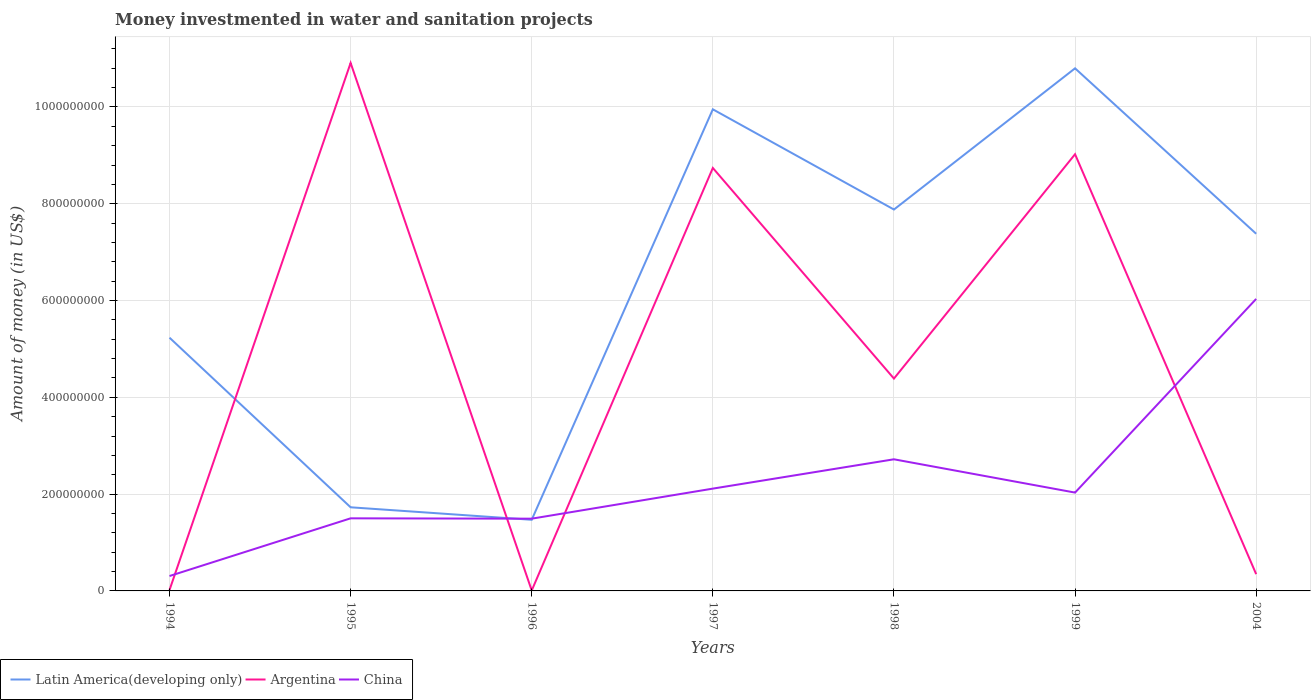Does the line corresponding to China intersect with the line corresponding to Argentina?
Your answer should be very brief. Yes. Is the number of lines equal to the number of legend labels?
Offer a very short reply. Yes. Across all years, what is the maximum money investmented in water and sanitation projects in China?
Provide a succinct answer. 3.08e+07. What is the total money investmented in water and sanitation projects in Argentina in the graph?
Your answer should be compact. -9.02e+08. What is the difference between the highest and the second highest money investmented in water and sanitation projects in Latin America(developing only)?
Your answer should be very brief. 9.33e+08. What is the difference between the highest and the lowest money investmented in water and sanitation projects in Latin America(developing only)?
Your answer should be very brief. 4. How many lines are there?
Offer a very short reply. 3. Does the graph contain any zero values?
Your response must be concise. No. Does the graph contain grids?
Ensure brevity in your answer.  Yes. Where does the legend appear in the graph?
Your answer should be compact. Bottom left. How many legend labels are there?
Your response must be concise. 3. What is the title of the graph?
Your answer should be very brief. Money investmented in water and sanitation projects. What is the label or title of the Y-axis?
Make the answer very short. Amount of money (in US$). What is the Amount of money (in US$) in Latin America(developing only) in 1994?
Make the answer very short. 5.23e+08. What is the Amount of money (in US$) in Argentina in 1994?
Keep it short and to the point. 1.90e+06. What is the Amount of money (in US$) of China in 1994?
Keep it short and to the point. 3.08e+07. What is the Amount of money (in US$) of Latin America(developing only) in 1995?
Your answer should be compact. 1.73e+08. What is the Amount of money (in US$) in Argentina in 1995?
Your answer should be compact. 1.09e+09. What is the Amount of money (in US$) in China in 1995?
Your response must be concise. 1.50e+08. What is the Amount of money (in US$) of Latin America(developing only) in 1996?
Provide a short and direct response. 1.47e+08. What is the Amount of money (in US$) of China in 1996?
Your answer should be very brief. 1.49e+08. What is the Amount of money (in US$) of Latin America(developing only) in 1997?
Make the answer very short. 9.95e+08. What is the Amount of money (in US$) of Argentina in 1997?
Keep it short and to the point. 8.74e+08. What is the Amount of money (in US$) in China in 1997?
Offer a very short reply. 2.11e+08. What is the Amount of money (in US$) in Latin America(developing only) in 1998?
Keep it short and to the point. 7.88e+08. What is the Amount of money (in US$) in Argentina in 1998?
Provide a short and direct response. 4.39e+08. What is the Amount of money (in US$) of China in 1998?
Your response must be concise. 2.72e+08. What is the Amount of money (in US$) of Latin America(developing only) in 1999?
Provide a short and direct response. 1.08e+09. What is the Amount of money (in US$) in Argentina in 1999?
Your response must be concise. 9.02e+08. What is the Amount of money (in US$) in China in 1999?
Your answer should be very brief. 2.03e+08. What is the Amount of money (in US$) of Latin America(developing only) in 2004?
Offer a terse response. 7.38e+08. What is the Amount of money (in US$) of Argentina in 2004?
Make the answer very short. 3.46e+07. What is the Amount of money (in US$) of China in 2004?
Your answer should be very brief. 6.03e+08. Across all years, what is the maximum Amount of money (in US$) of Latin America(developing only)?
Your response must be concise. 1.08e+09. Across all years, what is the maximum Amount of money (in US$) of Argentina?
Ensure brevity in your answer.  1.09e+09. Across all years, what is the maximum Amount of money (in US$) in China?
Keep it short and to the point. 6.03e+08. Across all years, what is the minimum Amount of money (in US$) of Latin America(developing only)?
Keep it short and to the point. 1.47e+08. Across all years, what is the minimum Amount of money (in US$) in China?
Ensure brevity in your answer.  3.08e+07. What is the total Amount of money (in US$) of Latin America(developing only) in the graph?
Give a very brief answer. 4.44e+09. What is the total Amount of money (in US$) of Argentina in the graph?
Provide a short and direct response. 3.34e+09. What is the total Amount of money (in US$) in China in the graph?
Your answer should be very brief. 1.62e+09. What is the difference between the Amount of money (in US$) in Latin America(developing only) in 1994 and that in 1995?
Your answer should be very brief. 3.50e+08. What is the difference between the Amount of money (in US$) in Argentina in 1994 and that in 1995?
Your answer should be very brief. -1.09e+09. What is the difference between the Amount of money (in US$) in China in 1994 and that in 1995?
Ensure brevity in your answer.  -1.19e+08. What is the difference between the Amount of money (in US$) in Latin America(developing only) in 1994 and that in 1996?
Offer a very short reply. 3.76e+08. What is the difference between the Amount of money (in US$) of Argentina in 1994 and that in 1996?
Provide a succinct answer. 1.00e+06. What is the difference between the Amount of money (in US$) of China in 1994 and that in 1996?
Make the answer very short. -1.18e+08. What is the difference between the Amount of money (in US$) in Latin America(developing only) in 1994 and that in 1997?
Make the answer very short. -4.72e+08. What is the difference between the Amount of money (in US$) in Argentina in 1994 and that in 1997?
Offer a terse response. -8.72e+08. What is the difference between the Amount of money (in US$) of China in 1994 and that in 1997?
Make the answer very short. -1.81e+08. What is the difference between the Amount of money (in US$) in Latin America(developing only) in 1994 and that in 1998?
Offer a terse response. -2.65e+08. What is the difference between the Amount of money (in US$) in Argentina in 1994 and that in 1998?
Offer a terse response. -4.37e+08. What is the difference between the Amount of money (in US$) in China in 1994 and that in 1998?
Ensure brevity in your answer.  -2.41e+08. What is the difference between the Amount of money (in US$) in Latin America(developing only) in 1994 and that in 1999?
Your answer should be compact. -5.57e+08. What is the difference between the Amount of money (in US$) in Argentina in 1994 and that in 1999?
Provide a short and direct response. -9.00e+08. What is the difference between the Amount of money (in US$) of China in 1994 and that in 1999?
Provide a short and direct response. -1.72e+08. What is the difference between the Amount of money (in US$) of Latin America(developing only) in 1994 and that in 2004?
Offer a very short reply. -2.15e+08. What is the difference between the Amount of money (in US$) in Argentina in 1994 and that in 2004?
Ensure brevity in your answer.  -3.28e+07. What is the difference between the Amount of money (in US$) in China in 1994 and that in 2004?
Your answer should be compact. -5.73e+08. What is the difference between the Amount of money (in US$) of Latin America(developing only) in 1995 and that in 1996?
Your answer should be compact. 2.58e+07. What is the difference between the Amount of money (in US$) in Argentina in 1995 and that in 1996?
Give a very brief answer. 1.09e+09. What is the difference between the Amount of money (in US$) of Latin America(developing only) in 1995 and that in 1997?
Give a very brief answer. -8.22e+08. What is the difference between the Amount of money (in US$) in Argentina in 1995 and that in 1997?
Your response must be concise. 2.17e+08. What is the difference between the Amount of money (in US$) in China in 1995 and that in 1997?
Give a very brief answer. -6.14e+07. What is the difference between the Amount of money (in US$) in Latin America(developing only) in 1995 and that in 1998?
Provide a succinct answer. -6.15e+08. What is the difference between the Amount of money (in US$) in Argentina in 1995 and that in 1998?
Offer a terse response. 6.52e+08. What is the difference between the Amount of money (in US$) of China in 1995 and that in 1998?
Keep it short and to the point. -1.22e+08. What is the difference between the Amount of money (in US$) in Latin America(developing only) in 1995 and that in 1999?
Provide a short and direct response. -9.07e+08. What is the difference between the Amount of money (in US$) of Argentina in 1995 and that in 1999?
Keep it short and to the point. 1.89e+08. What is the difference between the Amount of money (in US$) of China in 1995 and that in 1999?
Ensure brevity in your answer.  -5.32e+07. What is the difference between the Amount of money (in US$) of Latin America(developing only) in 1995 and that in 2004?
Make the answer very short. -5.65e+08. What is the difference between the Amount of money (in US$) in Argentina in 1995 and that in 2004?
Give a very brief answer. 1.06e+09. What is the difference between the Amount of money (in US$) of China in 1995 and that in 2004?
Your response must be concise. -4.53e+08. What is the difference between the Amount of money (in US$) in Latin America(developing only) in 1996 and that in 1997?
Your response must be concise. -8.48e+08. What is the difference between the Amount of money (in US$) in Argentina in 1996 and that in 1997?
Your answer should be compact. -8.73e+08. What is the difference between the Amount of money (in US$) in China in 1996 and that in 1997?
Provide a succinct answer. -6.21e+07. What is the difference between the Amount of money (in US$) of Latin America(developing only) in 1996 and that in 1998?
Give a very brief answer. -6.41e+08. What is the difference between the Amount of money (in US$) of Argentina in 1996 and that in 1998?
Offer a very short reply. -4.38e+08. What is the difference between the Amount of money (in US$) in China in 1996 and that in 1998?
Your answer should be compact. -1.23e+08. What is the difference between the Amount of money (in US$) in Latin America(developing only) in 1996 and that in 1999?
Offer a very short reply. -9.33e+08. What is the difference between the Amount of money (in US$) in Argentina in 1996 and that in 1999?
Provide a short and direct response. -9.02e+08. What is the difference between the Amount of money (in US$) of China in 1996 and that in 1999?
Provide a succinct answer. -5.39e+07. What is the difference between the Amount of money (in US$) in Latin America(developing only) in 1996 and that in 2004?
Your answer should be very brief. -5.91e+08. What is the difference between the Amount of money (in US$) in Argentina in 1996 and that in 2004?
Offer a terse response. -3.38e+07. What is the difference between the Amount of money (in US$) in China in 1996 and that in 2004?
Provide a short and direct response. -4.54e+08. What is the difference between the Amount of money (in US$) in Latin America(developing only) in 1997 and that in 1998?
Keep it short and to the point. 2.07e+08. What is the difference between the Amount of money (in US$) of Argentina in 1997 and that in 1998?
Your answer should be very brief. 4.35e+08. What is the difference between the Amount of money (in US$) of China in 1997 and that in 1998?
Offer a very short reply. -6.06e+07. What is the difference between the Amount of money (in US$) in Latin America(developing only) in 1997 and that in 1999?
Your response must be concise. -8.47e+07. What is the difference between the Amount of money (in US$) of Argentina in 1997 and that in 1999?
Ensure brevity in your answer.  -2.84e+07. What is the difference between the Amount of money (in US$) in China in 1997 and that in 1999?
Offer a terse response. 8.20e+06. What is the difference between the Amount of money (in US$) in Latin America(developing only) in 1997 and that in 2004?
Keep it short and to the point. 2.57e+08. What is the difference between the Amount of money (in US$) in Argentina in 1997 and that in 2004?
Your answer should be very brief. 8.39e+08. What is the difference between the Amount of money (in US$) of China in 1997 and that in 2004?
Offer a very short reply. -3.92e+08. What is the difference between the Amount of money (in US$) in Latin America(developing only) in 1998 and that in 1999?
Your response must be concise. -2.92e+08. What is the difference between the Amount of money (in US$) of Argentina in 1998 and that in 1999?
Offer a very short reply. -4.64e+08. What is the difference between the Amount of money (in US$) in China in 1998 and that in 1999?
Offer a terse response. 6.88e+07. What is the difference between the Amount of money (in US$) of Latin America(developing only) in 1998 and that in 2004?
Provide a succinct answer. 5.01e+07. What is the difference between the Amount of money (in US$) in Argentina in 1998 and that in 2004?
Your answer should be very brief. 4.04e+08. What is the difference between the Amount of money (in US$) in China in 1998 and that in 2004?
Provide a short and direct response. -3.31e+08. What is the difference between the Amount of money (in US$) in Latin America(developing only) in 1999 and that in 2004?
Provide a short and direct response. 3.42e+08. What is the difference between the Amount of money (in US$) in Argentina in 1999 and that in 2004?
Offer a very short reply. 8.68e+08. What is the difference between the Amount of money (in US$) of China in 1999 and that in 2004?
Make the answer very short. -4.00e+08. What is the difference between the Amount of money (in US$) of Latin America(developing only) in 1994 and the Amount of money (in US$) of Argentina in 1995?
Offer a very short reply. -5.68e+08. What is the difference between the Amount of money (in US$) in Latin America(developing only) in 1994 and the Amount of money (in US$) in China in 1995?
Offer a very short reply. 3.73e+08. What is the difference between the Amount of money (in US$) of Argentina in 1994 and the Amount of money (in US$) of China in 1995?
Offer a terse response. -1.48e+08. What is the difference between the Amount of money (in US$) of Latin America(developing only) in 1994 and the Amount of money (in US$) of Argentina in 1996?
Give a very brief answer. 5.22e+08. What is the difference between the Amount of money (in US$) of Latin America(developing only) in 1994 and the Amount of money (in US$) of China in 1996?
Provide a short and direct response. 3.74e+08. What is the difference between the Amount of money (in US$) of Argentina in 1994 and the Amount of money (in US$) of China in 1996?
Offer a terse response. -1.47e+08. What is the difference between the Amount of money (in US$) in Latin America(developing only) in 1994 and the Amount of money (in US$) in Argentina in 1997?
Provide a short and direct response. -3.51e+08. What is the difference between the Amount of money (in US$) of Latin America(developing only) in 1994 and the Amount of money (in US$) of China in 1997?
Offer a very short reply. 3.12e+08. What is the difference between the Amount of money (in US$) of Argentina in 1994 and the Amount of money (in US$) of China in 1997?
Make the answer very short. -2.10e+08. What is the difference between the Amount of money (in US$) in Latin America(developing only) in 1994 and the Amount of money (in US$) in Argentina in 1998?
Your answer should be very brief. 8.45e+07. What is the difference between the Amount of money (in US$) in Latin America(developing only) in 1994 and the Amount of money (in US$) in China in 1998?
Your answer should be compact. 2.51e+08. What is the difference between the Amount of money (in US$) of Argentina in 1994 and the Amount of money (in US$) of China in 1998?
Ensure brevity in your answer.  -2.70e+08. What is the difference between the Amount of money (in US$) of Latin America(developing only) in 1994 and the Amount of money (in US$) of Argentina in 1999?
Provide a succinct answer. -3.79e+08. What is the difference between the Amount of money (in US$) in Latin America(developing only) in 1994 and the Amount of money (in US$) in China in 1999?
Your answer should be compact. 3.20e+08. What is the difference between the Amount of money (in US$) of Argentina in 1994 and the Amount of money (in US$) of China in 1999?
Your answer should be compact. -2.01e+08. What is the difference between the Amount of money (in US$) of Latin America(developing only) in 1994 and the Amount of money (in US$) of Argentina in 2004?
Provide a short and direct response. 4.89e+08. What is the difference between the Amount of money (in US$) of Latin America(developing only) in 1994 and the Amount of money (in US$) of China in 2004?
Give a very brief answer. -8.01e+07. What is the difference between the Amount of money (in US$) of Argentina in 1994 and the Amount of money (in US$) of China in 2004?
Offer a terse response. -6.01e+08. What is the difference between the Amount of money (in US$) in Latin America(developing only) in 1995 and the Amount of money (in US$) in Argentina in 1996?
Provide a short and direct response. 1.72e+08. What is the difference between the Amount of money (in US$) of Latin America(developing only) in 1995 and the Amount of money (in US$) of China in 1996?
Offer a terse response. 2.35e+07. What is the difference between the Amount of money (in US$) of Argentina in 1995 and the Amount of money (in US$) of China in 1996?
Offer a very short reply. 9.42e+08. What is the difference between the Amount of money (in US$) of Latin America(developing only) in 1995 and the Amount of money (in US$) of Argentina in 1997?
Your answer should be compact. -7.01e+08. What is the difference between the Amount of money (in US$) of Latin America(developing only) in 1995 and the Amount of money (in US$) of China in 1997?
Ensure brevity in your answer.  -3.86e+07. What is the difference between the Amount of money (in US$) in Argentina in 1995 and the Amount of money (in US$) in China in 1997?
Offer a terse response. 8.80e+08. What is the difference between the Amount of money (in US$) in Latin America(developing only) in 1995 and the Amount of money (in US$) in Argentina in 1998?
Provide a short and direct response. -2.66e+08. What is the difference between the Amount of money (in US$) of Latin America(developing only) in 1995 and the Amount of money (in US$) of China in 1998?
Offer a very short reply. -9.92e+07. What is the difference between the Amount of money (in US$) of Argentina in 1995 and the Amount of money (in US$) of China in 1998?
Keep it short and to the point. 8.19e+08. What is the difference between the Amount of money (in US$) in Latin America(developing only) in 1995 and the Amount of money (in US$) in Argentina in 1999?
Offer a terse response. -7.30e+08. What is the difference between the Amount of money (in US$) in Latin America(developing only) in 1995 and the Amount of money (in US$) in China in 1999?
Ensure brevity in your answer.  -3.04e+07. What is the difference between the Amount of money (in US$) of Argentina in 1995 and the Amount of money (in US$) of China in 1999?
Make the answer very short. 8.88e+08. What is the difference between the Amount of money (in US$) of Latin America(developing only) in 1995 and the Amount of money (in US$) of Argentina in 2004?
Make the answer very short. 1.38e+08. What is the difference between the Amount of money (in US$) of Latin America(developing only) in 1995 and the Amount of money (in US$) of China in 2004?
Ensure brevity in your answer.  -4.31e+08. What is the difference between the Amount of money (in US$) of Argentina in 1995 and the Amount of money (in US$) of China in 2004?
Provide a short and direct response. 4.88e+08. What is the difference between the Amount of money (in US$) of Latin America(developing only) in 1996 and the Amount of money (in US$) of Argentina in 1997?
Give a very brief answer. -7.27e+08. What is the difference between the Amount of money (in US$) of Latin America(developing only) in 1996 and the Amount of money (in US$) of China in 1997?
Give a very brief answer. -6.44e+07. What is the difference between the Amount of money (in US$) of Argentina in 1996 and the Amount of money (in US$) of China in 1997?
Give a very brief answer. -2.10e+08. What is the difference between the Amount of money (in US$) of Latin America(developing only) in 1996 and the Amount of money (in US$) of Argentina in 1998?
Your response must be concise. -2.92e+08. What is the difference between the Amount of money (in US$) of Latin America(developing only) in 1996 and the Amount of money (in US$) of China in 1998?
Make the answer very short. -1.25e+08. What is the difference between the Amount of money (in US$) in Argentina in 1996 and the Amount of money (in US$) in China in 1998?
Provide a succinct answer. -2.71e+08. What is the difference between the Amount of money (in US$) in Latin America(developing only) in 1996 and the Amount of money (in US$) in Argentina in 1999?
Offer a very short reply. -7.55e+08. What is the difference between the Amount of money (in US$) of Latin America(developing only) in 1996 and the Amount of money (in US$) of China in 1999?
Your response must be concise. -5.62e+07. What is the difference between the Amount of money (in US$) of Argentina in 1996 and the Amount of money (in US$) of China in 1999?
Keep it short and to the point. -2.02e+08. What is the difference between the Amount of money (in US$) in Latin America(developing only) in 1996 and the Amount of money (in US$) in Argentina in 2004?
Ensure brevity in your answer.  1.12e+08. What is the difference between the Amount of money (in US$) of Latin America(developing only) in 1996 and the Amount of money (in US$) of China in 2004?
Give a very brief answer. -4.56e+08. What is the difference between the Amount of money (in US$) of Argentina in 1996 and the Amount of money (in US$) of China in 2004?
Your answer should be compact. -6.02e+08. What is the difference between the Amount of money (in US$) of Latin America(developing only) in 1997 and the Amount of money (in US$) of Argentina in 1998?
Your answer should be very brief. 5.56e+08. What is the difference between the Amount of money (in US$) in Latin America(developing only) in 1997 and the Amount of money (in US$) in China in 1998?
Your response must be concise. 7.23e+08. What is the difference between the Amount of money (in US$) in Argentina in 1997 and the Amount of money (in US$) in China in 1998?
Your answer should be very brief. 6.02e+08. What is the difference between the Amount of money (in US$) of Latin America(developing only) in 1997 and the Amount of money (in US$) of Argentina in 1999?
Your answer should be compact. 9.28e+07. What is the difference between the Amount of money (in US$) in Latin America(developing only) in 1997 and the Amount of money (in US$) in China in 1999?
Your answer should be compact. 7.92e+08. What is the difference between the Amount of money (in US$) of Argentina in 1997 and the Amount of money (in US$) of China in 1999?
Make the answer very short. 6.71e+08. What is the difference between the Amount of money (in US$) of Latin America(developing only) in 1997 and the Amount of money (in US$) of Argentina in 2004?
Provide a short and direct response. 9.61e+08. What is the difference between the Amount of money (in US$) in Latin America(developing only) in 1997 and the Amount of money (in US$) in China in 2004?
Ensure brevity in your answer.  3.92e+08. What is the difference between the Amount of money (in US$) of Argentina in 1997 and the Amount of money (in US$) of China in 2004?
Provide a succinct answer. 2.71e+08. What is the difference between the Amount of money (in US$) in Latin America(developing only) in 1998 and the Amount of money (in US$) in Argentina in 1999?
Your response must be concise. -1.14e+08. What is the difference between the Amount of money (in US$) of Latin America(developing only) in 1998 and the Amount of money (in US$) of China in 1999?
Give a very brief answer. 5.85e+08. What is the difference between the Amount of money (in US$) in Argentina in 1998 and the Amount of money (in US$) in China in 1999?
Give a very brief answer. 2.36e+08. What is the difference between the Amount of money (in US$) of Latin America(developing only) in 1998 and the Amount of money (in US$) of Argentina in 2004?
Keep it short and to the point. 7.53e+08. What is the difference between the Amount of money (in US$) in Latin America(developing only) in 1998 and the Amount of money (in US$) in China in 2004?
Make the answer very short. 1.85e+08. What is the difference between the Amount of money (in US$) of Argentina in 1998 and the Amount of money (in US$) of China in 2004?
Keep it short and to the point. -1.65e+08. What is the difference between the Amount of money (in US$) in Latin America(developing only) in 1999 and the Amount of money (in US$) in Argentina in 2004?
Your answer should be compact. 1.05e+09. What is the difference between the Amount of money (in US$) in Latin America(developing only) in 1999 and the Amount of money (in US$) in China in 2004?
Provide a succinct answer. 4.77e+08. What is the difference between the Amount of money (in US$) of Argentina in 1999 and the Amount of money (in US$) of China in 2004?
Offer a very short reply. 2.99e+08. What is the average Amount of money (in US$) of Latin America(developing only) per year?
Provide a succinct answer. 6.35e+08. What is the average Amount of money (in US$) of Argentina per year?
Provide a short and direct response. 4.78e+08. What is the average Amount of money (in US$) of China per year?
Your response must be concise. 2.31e+08. In the year 1994, what is the difference between the Amount of money (in US$) of Latin America(developing only) and Amount of money (in US$) of Argentina?
Ensure brevity in your answer.  5.21e+08. In the year 1994, what is the difference between the Amount of money (in US$) in Latin America(developing only) and Amount of money (in US$) in China?
Give a very brief answer. 4.92e+08. In the year 1994, what is the difference between the Amount of money (in US$) in Argentina and Amount of money (in US$) in China?
Your response must be concise. -2.89e+07. In the year 1995, what is the difference between the Amount of money (in US$) of Latin America(developing only) and Amount of money (in US$) of Argentina?
Your answer should be very brief. -9.18e+08. In the year 1995, what is the difference between the Amount of money (in US$) of Latin America(developing only) and Amount of money (in US$) of China?
Provide a succinct answer. 2.28e+07. In the year 1995, what is the difference between the Amount of money (in US$) in Argentina and Amount of money (in US$) in China?
Give a very brief answer. 9.41e+08. In the year 1996, what is the difference between the Amount of money (in US$) of Latin America(developing only) and Amount of money (in US$) of Argentina?
Offer a terse response. 1.46e+08. In the year 1996, what is the difference between the Amount of money (in US$) in Latin America(developing only) and Amount of money (in US$) in China?
Offer a very short reply. -2.30e+06. In the year 1996, what is the difference between the Amount of money (in US$) of Argentina and Amount of money (in US$) of China?
Keep it short and to the point. -1.48e+08. In the year 1997, what is the difference between the Amount of money (in US$) in Latin America(developing only) and Amount of money (in US$) in Argentina?
Provide a succinct answer. 1.21e+08. In the year 1997, what is the difference between the Amount of money (in US$) in Latin America(developing only) and Amount of money (in US$) in China?
Your response must be concise. 7.84e+08. In the year 1997, what is the difference between the Amount of money (in US$) in Argentina and Amount of money (in US$) in China?
Provide a short and direct response. 6.63e+08. In the year 1998, what is the difference between the Amount of money (in US$) in Latin America(developing only) and Amount of money (in US$) in Argentina?
Offer a terse response. 3.49e+08. In the year 1998, what is the difference between the Amount of money (in US$) in Latin America(developing only) and Amount of money (in US$) in China?
Offer a very short reply. 5.16e+08. In the year 1998, what is the difference between the Amount of money (in US$) of Argentina and Amount of money (in US$) of China?
Provide a short and direct response. 1.67e+08. In the year 1999, what is the difference between the Amount of money (in US$) in Latin America(developing only) and Amount of money (in US$) in Argentina?
Your answer should be very brief. 1.78e+08. In the year 1999, what is the difference between the Amount of money (in US$) in Latin America(developing only) and Amount of money (in US$) in China?
Keep it short and to the point. 8.77e+08. In the year 1999, what is the difference between the Amount of money (in US$) in Argentina and Amount of money (in US$) in China?
Provide a succinct answer. 6.99e+08. In the year 2004, what is the difference between the Amount of money (in US$) of Latin America(developing only) and Amount of money (in US$) of Argentina?
Make the answer very short. 7.03e+08. In the year 2004, what is the difference between the Amount of money (in US$) in Latin America(developing only) and Amount of money (in US$) in China?
Your response must be concise. 1.35e+08. In the year 2004, what is the difference between the Amount of money (in US$) in Argentina and Amount of money (in US$) in China?
Your response must be concise. -5.69e+08. What is the ratio of the Amount of money (in US$) of Latin America(developing only) in 1994 to that in 1995?
Make the answer very short. 3.03. What is the ratio of the Amount of money (in US$) of Argentina in 1994 to that in 1995?
Your answer should be compact. 0. What is the ratio of the Amount of money (in US$) of China in 1994 to that in 1995?
Offer a terse response. 0.21. What is the ratio of the Amount of money (in US$) of Latin America(developing only) in 1994 to that in 1996?
Provide a short and direct response. 3.56. What is the ratio of the Amount of money (in US$) in Argentina in 1994 to that in 1996?
Give a very brief answer. 2.11. What is the ratio of the Amount of money (in US$) of China in 1994 to that in 1996?
Make the answer very short. 0.21. What is the ratio of the Amount of money (in US$) in Latin America(developing only) in 1994 to that in 1997?
Offer a very short reply. 0.53. What is the ratio of the Amount of money (in US$) in Argentina in 1994 to that in 1997?
Your response must be concise. 0. What is the ratio of the Amount of money (in US$) of China in 1994 to that in 1997?
Provide a succinct answer. 0.15. What is the ratio of the Amount of money (in US$) of Latin America(developing only) in 1994 to that in 1998?
Offer a very short reply. 0.66. What is the ratio of the Amount of money (in US$) in Argentina in 1994 to that in 1998?
Your answer should be compact. 0. What is the ratio of the Amount of money (in US$) of China in 1994 to that in 1998?
Provide a short and direct response. 0.11. What is the ratio of the Amount of money (in US$) in Latin America(developing only) in 1994 to that in 1999?
Provide a succinct answer. 0.48. What is the ratio of the Amount of money (in US$) of Argentina in 1994 to that in 1999?
Your answer should be very brief. 0. What is the ratio of the Amount of money (in US$) in China in 1994 to that in 1999?
Keep it short and to the point. 0.15. What is the ratio of the Amount of money (in US$) of Latin America(developing only) in 1994 to that in 2004?
Offer a very short reply. 0.71. What is the ratio of the Amount of money (in US$) of Argentina in 1994 to that in 2004?
Provide a succinct answer. 0.05. What is the ratio of the Amount of money (in US$) of China in 1994 to that in 2004?
Keep it short and to the point. 0.05. What is the ratio of the Amount of money (in US$) in Latin America(developing only) in 1995 to that in 1996?
Offer a very short reply. 1.18. What is the ratio of the Amount of money (in US$) of Argentina in 1995 to that in 1996?
Ensure brevity in your answer.  1212.22. What is the ratio of the Amount of money (in US$) in Latin America(developing only) in 1995 to that in 1997?
Provide a short and direct response. 0.17. What is the ratio of the Amount of money (in US$) of Argentina in 1995 to that in 1997?
Keep it short and to the point. 1.25. What is the ratio of the Amount of money (in US$) of China in 1995 to that in 1997?
Make the answer very short. 0.71. What is the ratio of the Amount of money (in US$) of Latin America(developing only) in 1995 to that in 1998?
Provide a short and direct response. 0.22. What is the ratio of the Amount of money (in US$) of Argentina in 1995 to that in 1998?
Offer a very short reply. 2.49. What is the ratio of the Amount of money (in US$) of China in 1995 to that in 1998?
Your response must be concise. 0.55. What is the ratio of the Amount of money (in US$) of Latin America(developing only) in 1995 to that in 1999?
Offer a very short reply. 0.16. What is the ratio of the Amount of money (in US$) in Argentina in 1995 to that in 1999?
Make the answer very short. 1.21. What is the ratio of the Amount of money (in US$) of China in 1995 to that in 1999?
Your answer should be very brief. 0.74. What is the ratio of the Amount of money (in US$) of Latin America(developing only) in 1995 to that in 2004?
Offer a very short reply. 0.23. What is the ratio of the Amount of money (in US$) in Argentina in 1995 to that in 2004?
Make the answer very short. 31.49. What is the ratio of the Amount of money (in US$) of China in 1995 to that in 2004?
Give a very brief answer. 0.25. What is the ratio of the Amount of money (in US$) of Latin America(developing only) in 1996 to that in 1997?
Make the answer very short. 0.15. What is the ratio of the Amount of money (in US$) of Argentina in 1996 to that in 1997?
Keep it short and to the point. 0. What is the ratio of the Amount of money (in US$) in China in 1996 to that in 1997?
Ensure brevity in your answer.  0.71. What is the ratio of the Amount of money (in US$) of Latin America(developing only) in 1996 to that in 1998?
Your response must be concise. 0.19. What is the ratio of the Amount of money (in US$) of Argentina in 1996 to that in 1998?
Your answer should be very brief. 0. What is the ratio of the Amount of money (in US$) in China in 1996 to that in 1998?
Ensure brevity in your answer.  0.55. What is the ratio of the Amount of money (in US$) of Latin America(developing only) in 1996 to that in 1999?
Keep it short and to the point. 0.14. What is the ratio of the Amount of money (in US$) of China in 1996 to that in 1999?
Give a very brief answer. 0.73. What is the ratio of the Amount of money (in US$) in Latin America(developing only) in 1996 to that in 2004?
Provide a short and direct response. 0.2. What is the ratio of the Amount of money (in US$) in Argentina in 1996 to that in 2004?
Give a very brief answer. 0.03. What is the ratio of the Amount of money (in US$) of China in 1996 to that in 2004?
Offer a terse response. 0.25. What is the ratio of the Amount of money (in US$) of Latin America(developing only) in 1997 to that in 1998?
Offer a very short reply. 1.26. What is the ratio of the Amount of money (in US$) of Argentina in 1997 to that in 1998?
Provide a short and direct response. 1.99. What is the ratio of the Amount of money (in US$) of China in 1997 to that in 1998?
Provide a short and direct response. 0.78. What is the ratio of the Amount of money (in US$) in Latin America(developing only) in 1997 to that in 1999?
Offer a very short reply. 0.92. What is the ratio of the Amount of money (in US$) of Argentina in 1997 to that in 1999?
Offer a terse response. 0.97. What is the ratio of the Amount of money (in US$) in China in 1997 to that in 1999?
Keep it short and to the point. 1.04. What is the ratio of the Amount of money (in US$) of Latin America(developing only) in 1997 to that in 2004?
Offer a terse response. 1.35. What is the ratio of the Amount of money (in US$) in Argentina in 1997 to that in 2004?
Ensure brevity in your answer.  25.22. What is the ratio of the Amount of money (in US$) in China in 1997 to that in 2004?
Your answer should be compact. 0.35. What is the ratio of the Amount of money (in US$) of Latin America(developing only) in 1998 to that in 1999?
Give a very brief answer. 0.73. What is the ratio of the Amount of money (in US$) in Argentina in 1998 to that in 1999?
Your response must be concise. 0.49. What is the ratio of the Amount of money (in US$) in China in 1998 to that in 1999?
Make the answer very short. 1.34. What is the ratio of the Amount of money (in US$) of Latin America(developing only) in 1998 to that in 2004?
Your answer should be very brief. 1.07. What is the ratio of the Amount of money (in US$) in Argentina in 1998 to that in 2004?
Your answer should be very brief. 12.66. What is the ratio of the Amount of money (in US$) in China in 1998 to that in 2004?
Your answer should be compact. 0.45. What is the ratio of the Amount of money (in US$) in Latin America(developing only) in 1999 to that in 2004?
Give a very brief answer. 1.46. What is the ratio of the Amount of money (in US$) of Argentina in 1999 to that in 2004?
Provide a succinct answer. 26.04. What is the ratio of the Amount of money (in US$) of China in 1999 to that in 2004?
Your answer should be very brief. 0.34. What is the difference between the highest and the second highest Amount of money (in US$) of Latin America(developing only)?
Your answer should be very brief. 8.47e+07. What is the difference between the highest and the second highest Amount of money (in US$) in Argentina?
Provide a succinct answer. 1.89e+08. What is the difference between the highest and the second highest Amount of money (in US$) in China?
Provide a short and direct response. 3.31e+08. What is the difference between the highest and the lowest Amount of money (in US$) in Latin America(developing only)?
Offer a very short reply. 9.33e+08. What is the difference between the highest and the lowest Amount of money (in US$) of Argentina?
Provide a succinct answer. 1.09e+09. What is the difference between the highest and the lowest Amount of money (in US$) of China?
Your answer should be compact. 5.73e+08. 